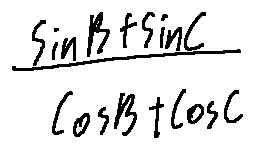Convert formula to latex. <formula><loc_0><loc_0><loc_500><loc_500>\frac { \sin B + \sin C } { \cos B + \cos C }</formula> 